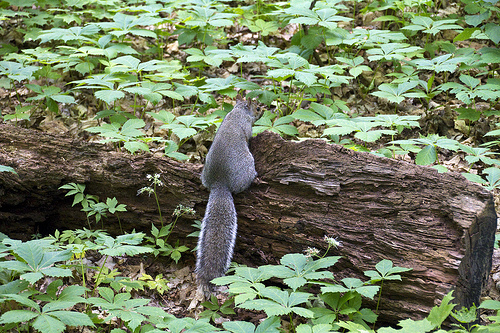<image>
Is there a squirrel on the wood bark? Yes. Looking at the image, I can see the squirrel is positioned on top of the wood bark, with the wood bark providing support. Is there a squirrel on the plant? No. The squirrel is not positioned on the plant. They may be near each other, but the squirrel is not supported by or resting on top of the plant. Is the fungus in the log? No. The fungus is not contained within the log. These objects have a different spatial relationship. 